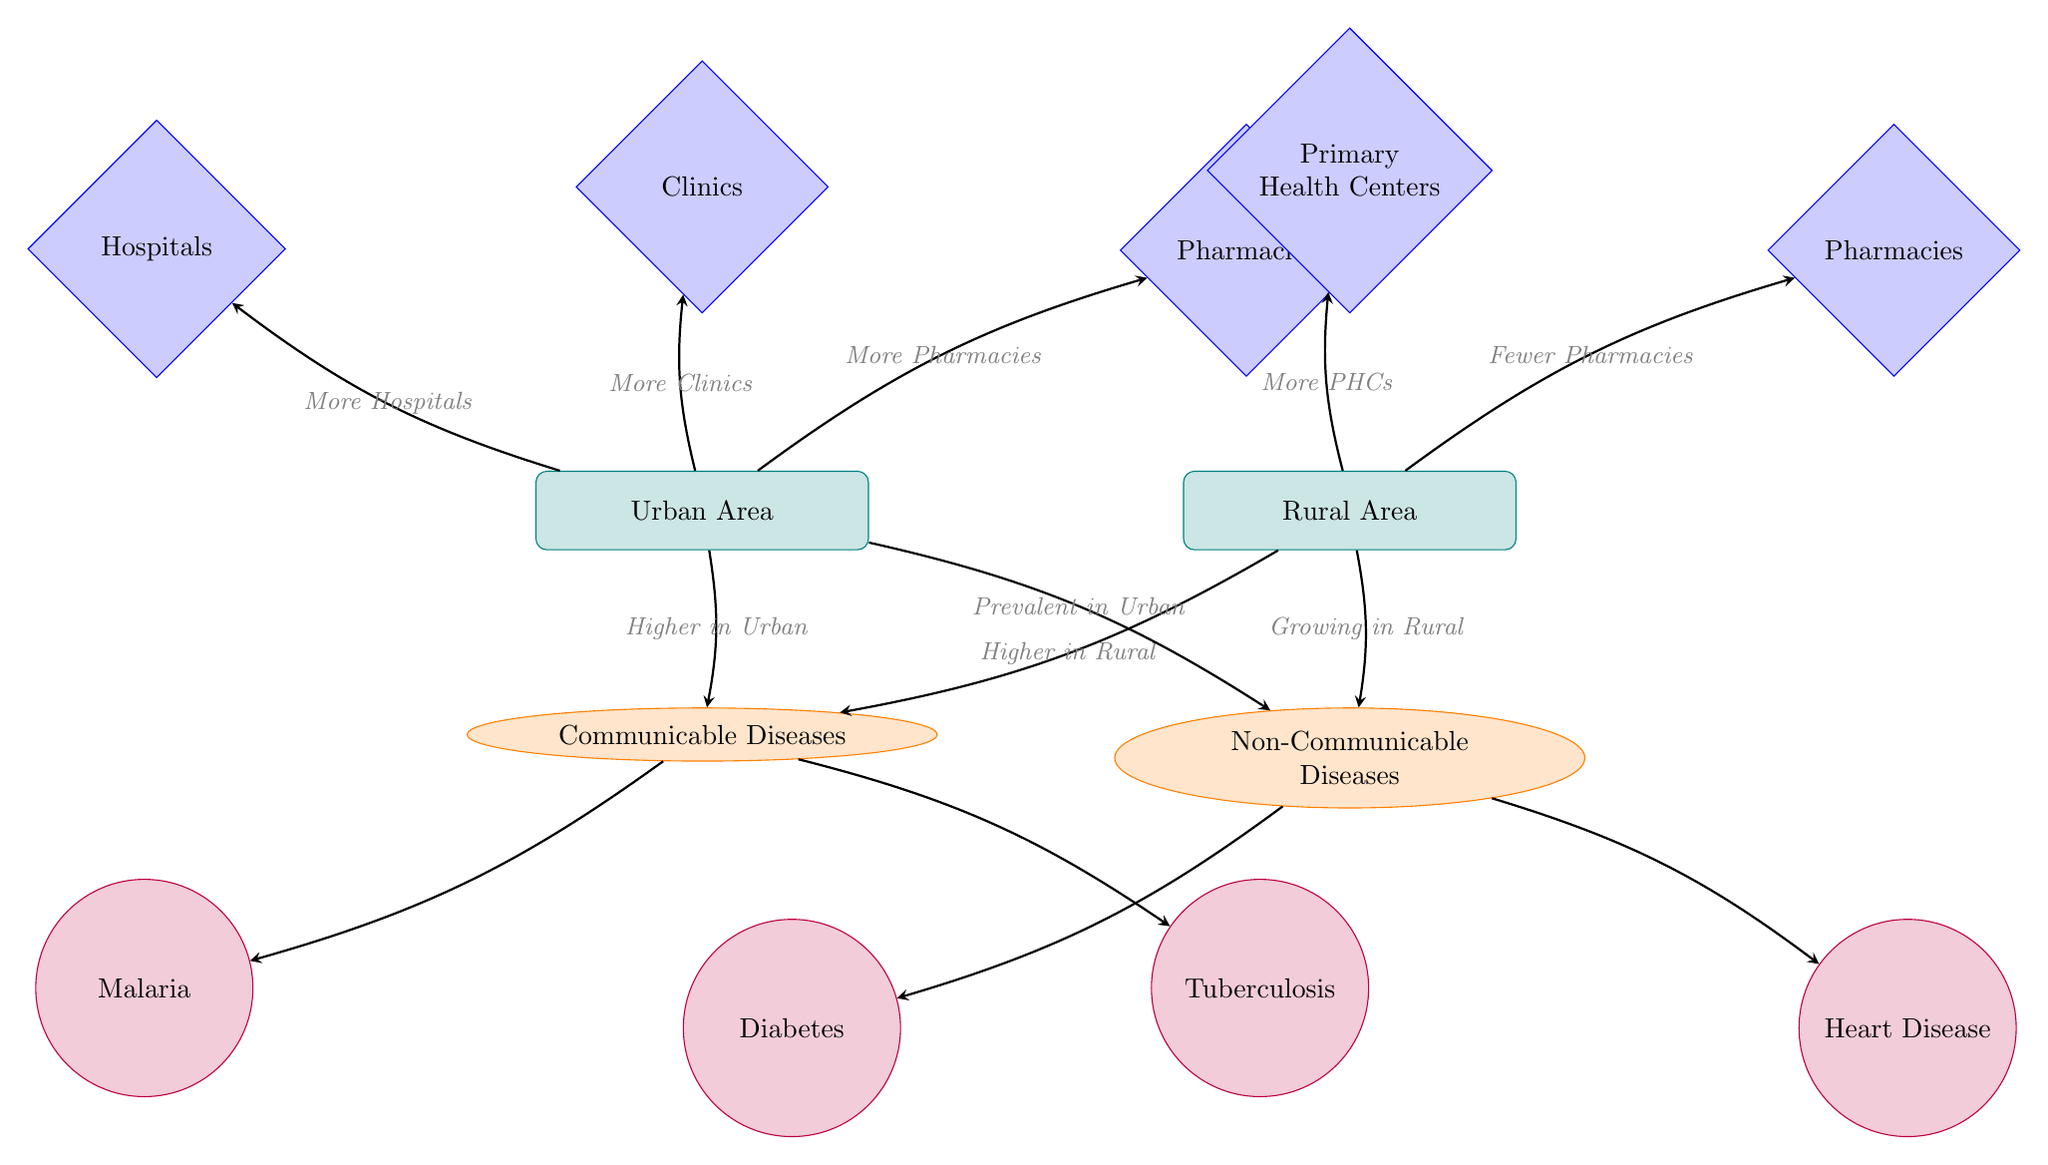What are the two types of diseases shown in the diagram? The diagram explicitly mentions two types of diseases: Communicable Diseases and Non-Communicable Diseases. These diseases are represented as distinct nodes below the urban and rural areas.
Answer: Communicable Diseases, Non-Communicable Diseases Which area has more hospitals, urban or rural? The diagram indicates that urban areas have more hospitals. This is shown by the arrow leading from the urban node to the hospitals node, labeled "More Hospitals."
Answer: Urban What disease is associated with malaria? The diagram illustrates that malaria is categorized under Communicable Diseases, which is linked to the specific, malaria node. It shows the direct connection between communicable diseases and specific diseases.
Answer: Malaria How many diseases are linked to Non-Communicable Diseases? Upon examining the diagram, there are two specific diseases linked to Non-Communicable Diseases: Diabetes and Heart Disease. These diseases can be counted from the nodes connected to the Non-Communicable Diseases node.
Answer: 2 What health resource is more prevalent in rural areas than urban areas? The diagram shows that Primary Health Centers (PHCs) are indicated as more prevalent in rural areas, as evidenced by the arrow "More PHCs" pointing from the rural area to the PHC node.
Answer: Primary Health Centers Which disease category is stated as growing in rural areas? The diagram specifies that Non-Communicable Diseases are noted as "Growing in Rural," indicated by the arrow connecting the rural node to the Non-Communicable Diseases node.
Answer: Non-Communicable Diseases How do the number of pharmacies compare between urban and rural areas? According to the diagram, urban areas have more pharmacies ("More Pharmacies"), while rural areas have fewer pharmacies ("Fewer Pharmacies") as indicated by the arrows leading to and from the pharmacy nodes.
Answer: More in Urban, Fewer in Rural What type of disease is tuberculosis categorized under? The diagram categorizes tuberculosis as a Communicable Disease, as it is directly represented below the Communicable Diseases node along with malaria.
Answer: Communicable Disease How many specific diseases are mentioned in total in the diagram? The diagram lists a total of four specific diseases: Malaria, Tuberculosis, Diabetes, and Heart Disease. By counting the specific nodes connected to both disease categories, we can establish the total number.
Answer: 4 